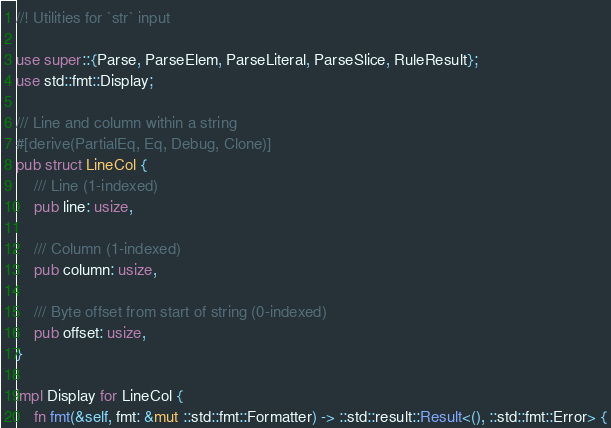<code> <loc_0><loc_0><loc_500><loc_500><_Rust_>//! Utilities for `str` input

use super::{Parse, ParseElem, ParseLiteral, ParseSlice, RuleResult};
use std::fmt::Display;

/// Line and column within a string
#[derive(PartialEq, Eq, Debug, Clone)]
pub struct LineCol {
    /// Line (1-indexed)
    pub line: usize,

    /// Column (1-indexed)
    pub column: usize,

    /// Byte offset from start of string (0-indexed)
    pub offset: usize,
}

impl Display for LineCol {
    fn fmt(&self, fmt: &mut ::std::fmt::Formatter) -> ::std::result::Result<(), ::std::fmt::Error> {</code> 